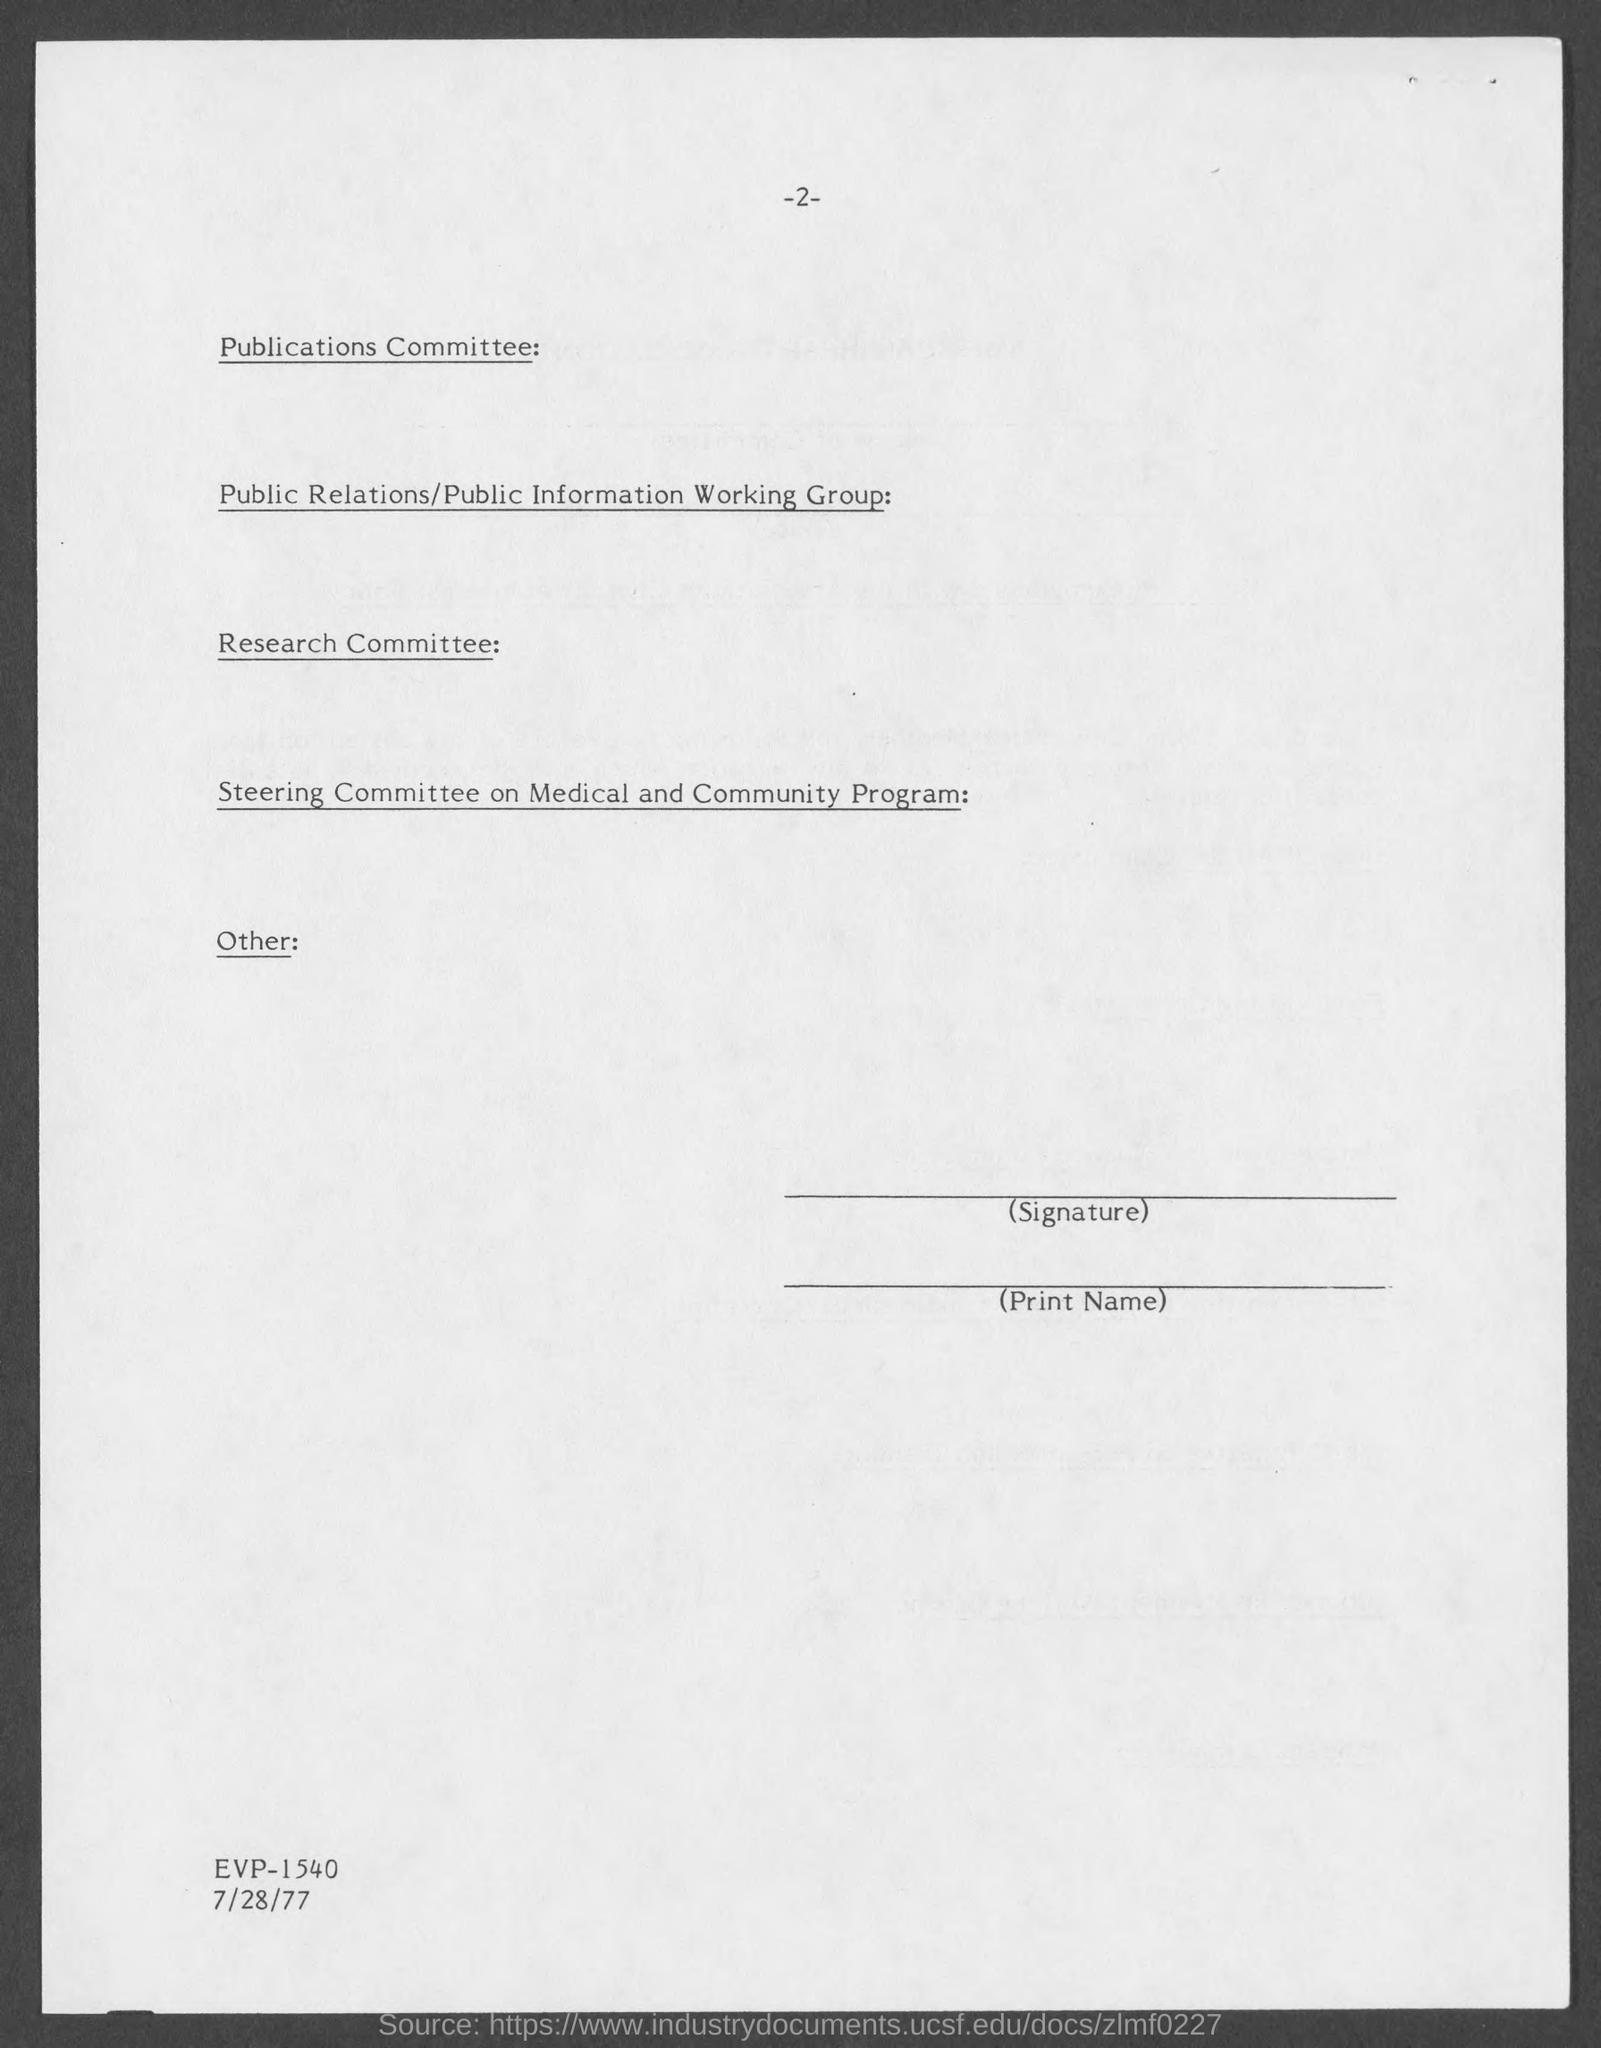What is the date?
Ensure brevity in your answer.  7/28/77. What is the page number of this document?
Offer a very short reply. 2. 